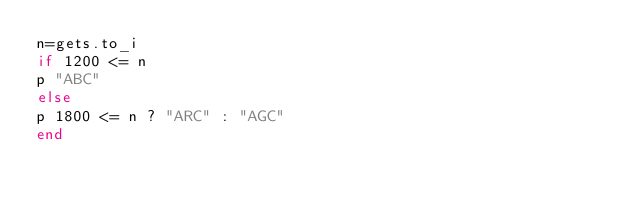Convert code to text. <code><loc_0><loc_0><loc_500><loc_500><_Ruby_>n=gets.to_i
if 1200 <= n
p "ABC"
else
p 1800 <= n ? "ARC" : "AGC"
end</code> 